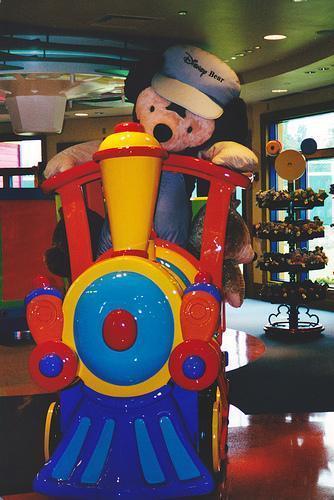How many stuffed animals are shown?
Give a very brief answer. 1. 